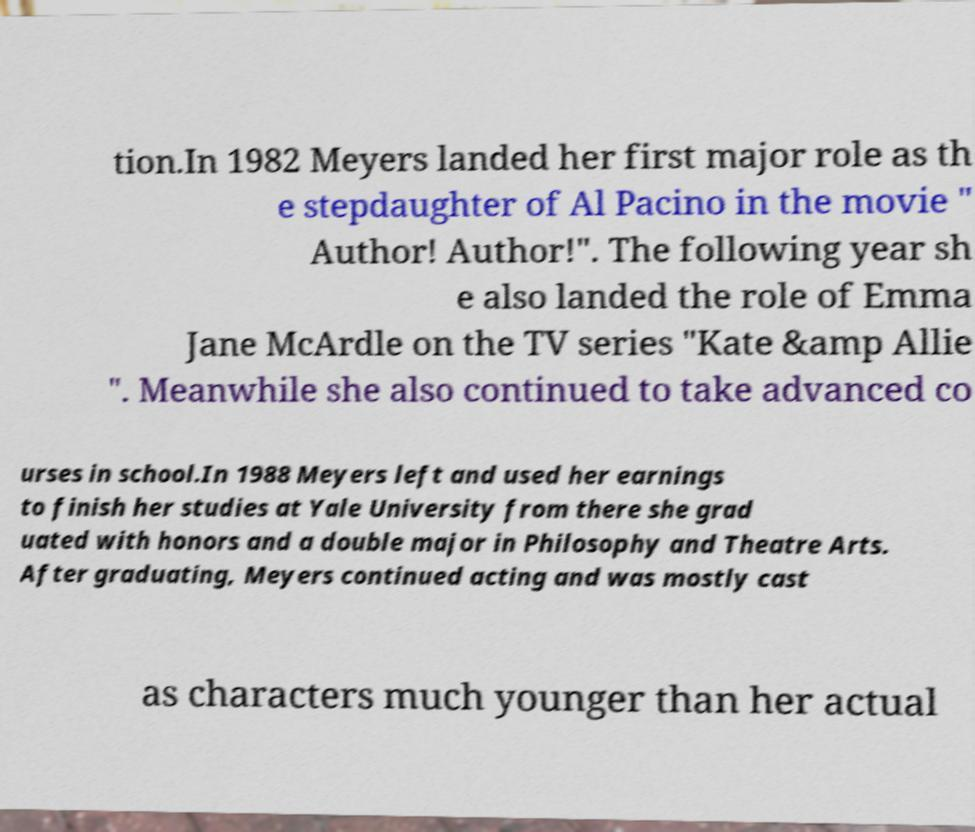Can you read and provide the text displayed in the image?This photo seems to have some interesting text. Can you extract and type it out for me? tion.In 1982 Meyers landed her first major role as th e stepdaughter of Al Pacino in the movie " Author! Author!". The following year sh e also landed the role of Emma Jane McArdle on the TV series "Kate &amp Allie ". Meanwhile she also continued to take advanced co urses in school.In 1988 Meyers left and used her earnings to finish her studies at Yale University from there she grad uated with honors and a double major in Philosophy and Theatre Arts. After graduating, Meyers continued acting and was mostly cast as characters much younger than her actual 